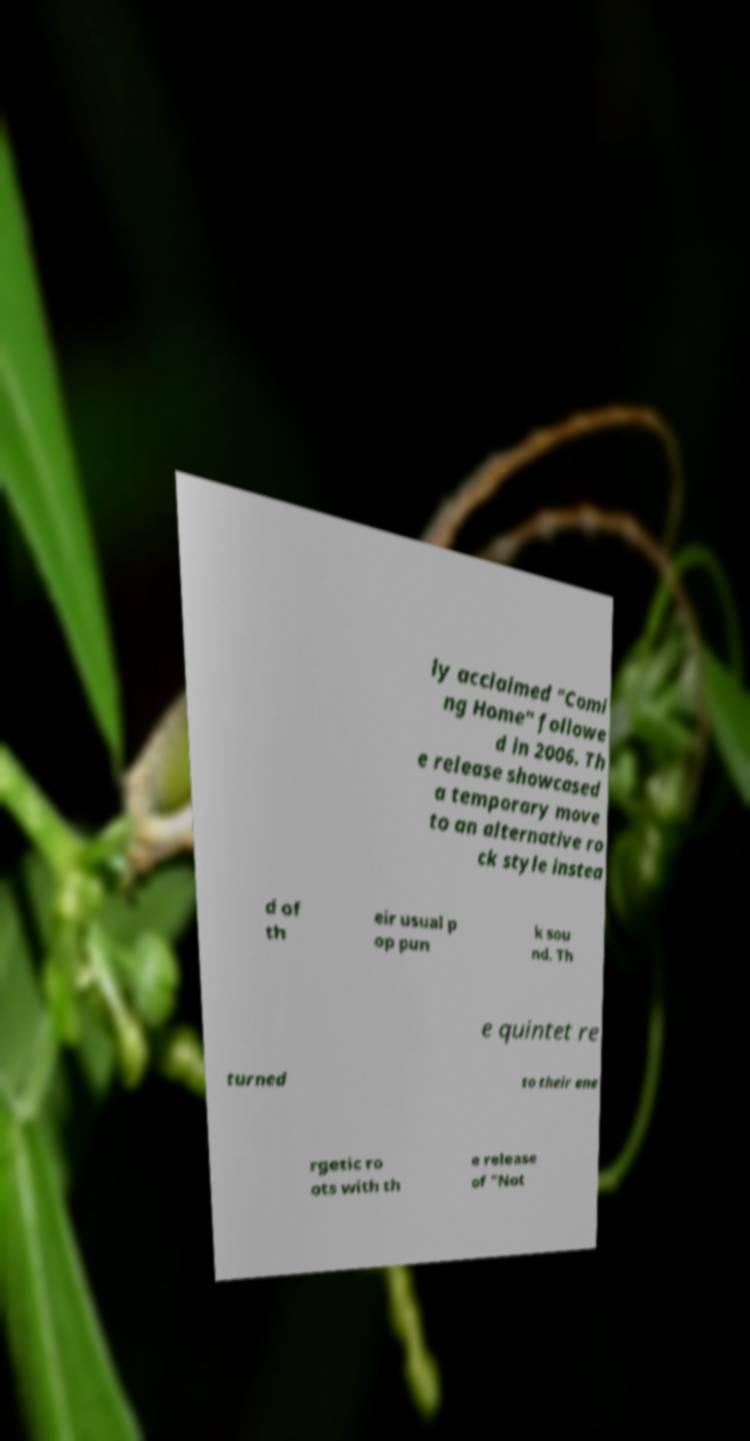For documentation purposes, I need the text within this image transcribed. Could you provide that? ly acclaimed "Comi ng Home" followe d in 2006. Th e release showcased a temporary move to an alternative ro ck style instea d of th eir usual p op pun k sou nd. Th e quintet re turned to their ene rgetic ro ots with th e release of "Not 